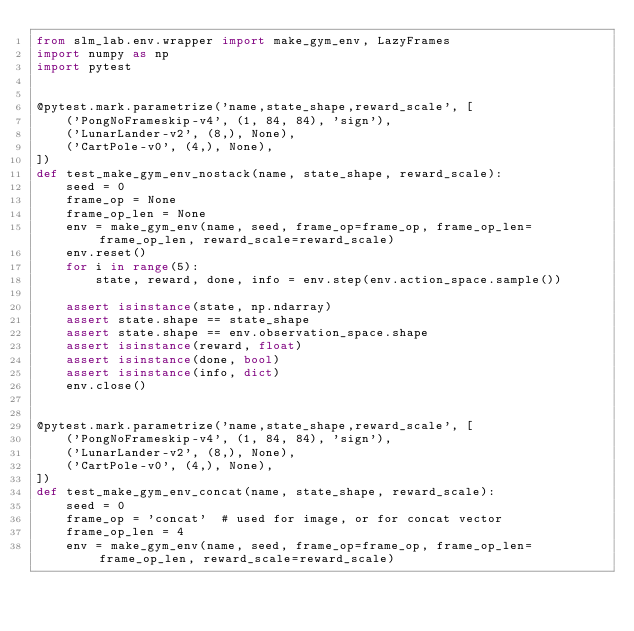<code> <loc_0><loc_0><loc_500><loc_500><_Python_>from slm_lab.env.wrapper import make_gym_env, LazyFrames
import numpy as np
import pytest


@pytest.mark.parametrize('name,state_shape,reward_scale', [
    ('PongNoFrameskip-v4', (1, 84, 84), 'sign'),
    ('LunarLander-v2', (8,), None),
    ('CartPole-v0', (4,), None),
])
def test_make_gym_env_nostack(name, state_shape, reward_scale):
    seed = 0
    frame_op = None
    frame_op_len = None
    env = make_gym_env(name, seed, frame_op=frame_op, frame_op_len=frame_op_len, reward_scale=reward_scale)
    env.reset()
    for i in range(5):
        state, reward, done, info = env.step(env.action_space.sample())

    assert isinstance(state, np.ndarray)
    assert state.shape == state_shape
    assert state.shape == env.observation_space.shape
    assert isinstance(reward, float)
    assert isinstance(done, bool)
    assert isinstance(info, dict)
    env.close()


@pytest.mark.parametrize('name,state_shape,reward_scale', [
    ('PongNoFrameskip-v4', (1, 84, 84), 'sign'),
    ('LunarLander-v2', (8,), None),
    ('CartPole-v0', (4,), None),
])
def test_make_gym_env_concat(name, state_shape, reward_scale):
    seed = 0
    frame_op = 'concat'  # used for image, or for concat vector
    frame_op_len = 4
    env = make_gym_env(name, seed, frame_op=frame_op, frame_op_len=frame_op_len, reward_scale=reward_scale)</code> 